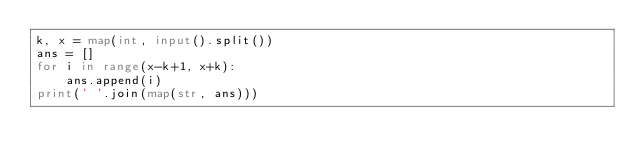Convert code to text. <code><loc_0><loc_0><loc_500><loc_500><_Python_>k, x = map(int, input().split())
ans = []
for i in range(x-k+1, x+k):
    ans.append(i)
print(' '.join(map(str, ans)))</code> 